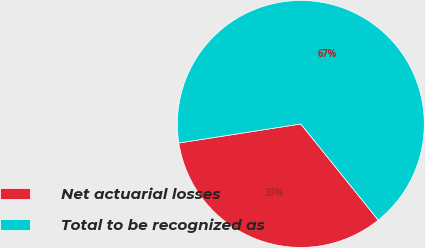<chart> <loc_0><loc_0><loc_500><loc_500><pie_chart><fcel>Net actuarial losses<fcel>Total to be recognized as<nl><fcel>33.33%<fcel>66.67%<nl></chart> 